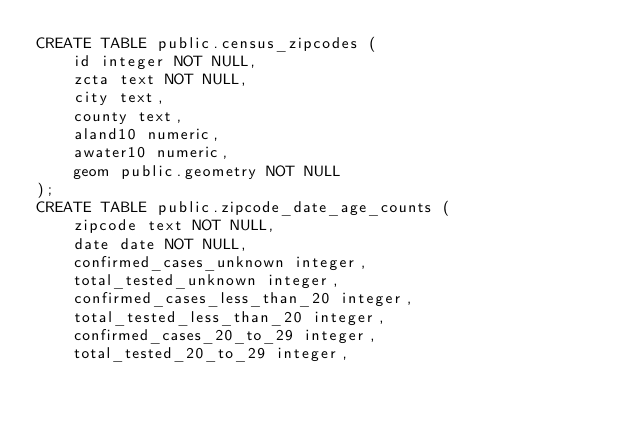<code> <loc_0><loc_0><loc_500><loc_500><_SQL_>CREATE TABLE public.census_zipcodes (
    id integer NOT NULL,
    zcta text NOT NULL,
    city text,
    county text,
    aland10 numeric,
    awater10 numeric,
    geom public.geometry NOT NULL
);
CREATE TABLE public.zipcode_date_age_counts (
    zipcode text NOT NULL,
    date date NOT NULL,
    confirmed_cases_unknown integer,
    total_tested_unknown integer,
    confirmed_cases_less_than_20 integer,
    total_tested_less_than_20 integer,
    confirmed_cases_20_to_29 integer,
    total_tested_20_to_29 integer,</code> 